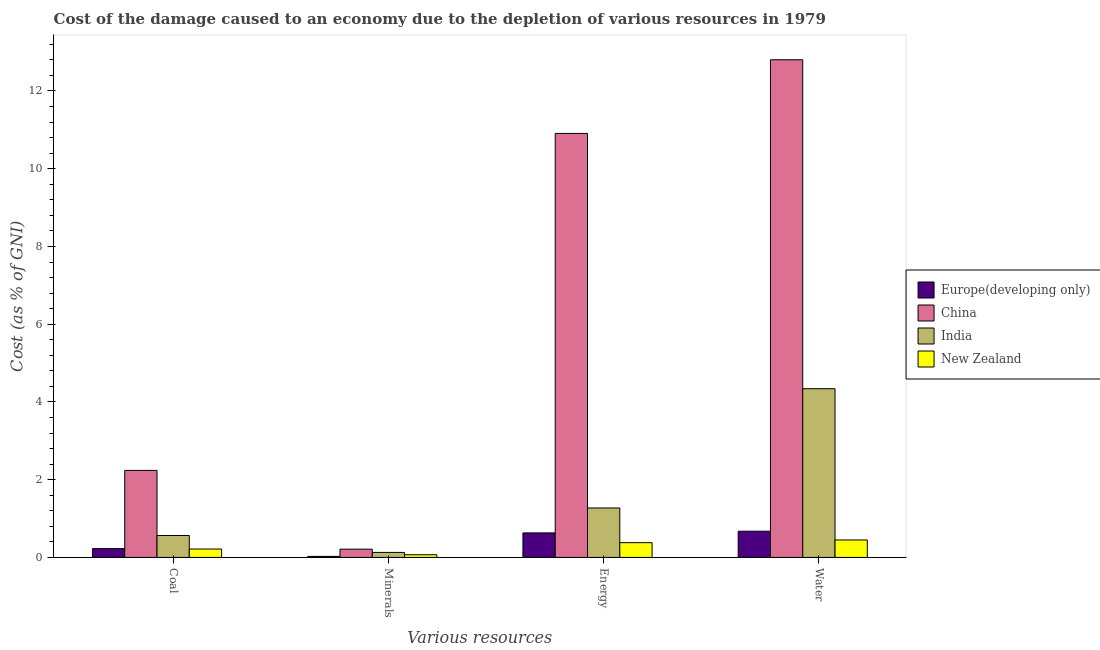How many different coloured bars are there?
Your response must be concise. 4. How many groups of bars are there?
Keep it short and to the point. 4. Are the number of bars per tick equal to the number of legend labels?
Your answer should be very brief. Yes. How many bars are there on the 4th tick from the left?
Provide a succinct answer. 4. How many bars are there on the 2nd tick from the right?
Your answer should be very brief. 4. What is the label of the 1st group of bars from the left?
Offer a terse response. Coal. What is the cost of damage due to depletion of minerals in China?
Offer a terse response. 0.21. Across all countries, what is the maximum cost of damage due to depletion of coal?
Provide a short and direct response. 2.24. Across all countries, what is the minimum cost of damage due to depletion of coal?
Keep it short and to the point. 0.22. In which country was the cost of damage due to depletion of water minimum?
Your answer should be very brief. New Zealand. What is the total cost of damage due to depletion of water in the graph?
Offer a very short reply. 18.27. What is the difference between the cost of damage due to depletion of water in Europe(developing only) and that in China?
Give a very brief answer. -12.13. What is the difference between the cost of damage due to depletion of energy in China and the cost of damage due to depletion of water in India?
Your answer should be compact. 6.57. What is the average cost of damage due to depletion of minerals per country?
Ensure brevity in your answer.  0.11. What is the difference between the cost of damage due to depletion of minerals and cost of damage due to depletion of coal in China?
Offer a terse response. -2.03. What is the ratio of the cost of damage due to depletion of coal in Europe(developing only) to that in India?
Provide a succinct answer. 0.4. Is the cost of damage due to depletion of coal in New Zealand less than that in Europe(developing only)?
Offer a terse response. Yes. Is the difference between the cost of damage due to depletion of water in New Zealand and China greater than the difference between the cost of damage due to depletion of coal in New Zealand and China?
Keep it short and to the point. No. What is the difference between the highest and the second highest cost of damage due to depletion of coal?
Ensure brevity in your answer.  1.67. What is the difference between the highest and the lowest cost of damage due to depletion of energy?
Your answer should be compact. 10.53. Is the sum of the cost of damage due to depletion of coal in China and New Zealand greater than the maximum cost of damage due to depletion of water across all countries?
Provide a succinct answer. No. What does the 3rd bar from the left in Water represents?
Make the answer very short. India. What does the 1st bar from the right in Coal represents?
Keep it short and to the point. New Zealand. Is it the case that in every country, the sum of the cost of damage due to depletion of coal and cost of damage due to depletion of minerals is greater than the cost of damage due to depletion of energy?
Offer a terse response. No. Are all the bars in the graph horizontal?
Offer a terse response. No. How many countries are there in the graph?
Your response must be concise. 4. Are the values on the major ticks of Y-axis written in scientific E-notation?
Keep it short and to the point. No. Does the graph contain any zero values?
Ensure brevity in your answer.  No. How many legend labels are there?
Your answer should be compact. 4. What is the title of the graph?
Your response must be concise. Cost of the damage caused to an economy due to the depletion of various resources in 1979 . What is the label or title of the X-axis?
Offer a very short reply. Various resources. What is the label or title of the Y-axis?
Offer a very short reply. Cost (as % of GNI). What is the Cost (as % of GNI) in Europe(developing only) in Coal?
Give a very brief answer. 0.23. What is the Cost (as % of GNI) of China in Coal?
Make the answer very short. 2.24. What is the Cost (as % of GNI) in India in Coal?
Your answer should be very brief. 0.56. What is the Cost (as % of GNI) in New Zealand in Coal?
Ensure brevity in your answer.  0.22. What is the Cost (as % of GNI) in Europe(developing only) in Minerals?
Your response must be concise. 0.03. What is the Cost (as % of GNI) of China in Minerals?
Your response must be concise. 0.21. What is the Cost (as % of GNI) of India in Minerals?
Keep it short and to the point. 0.13. What is the Cost (as % of GNI) of New Zealand in Minerals?
Offer a very short reply. 0.07. What is the Cost (as % of GNI) of Europe(developing only) in Energy?
Offer a very short reply. 0.63. What is the Cost (as % of GNI) in China in Energy?
Your answer should be compact. 10.91. What is the Cost (as % of GNI) of India in Energy?
Offer a terse response. 1.27. What is the Cost (as % of GNI) in New Zealand in Energy?
Keep it short and to the point. 0.38. What is the Cost (as % of GNI) of Europe(developing only) in Water?
Keep it short and to the point. 0.67. What is the Cost (as % of GNI) of China in Water?
Your answer should be compact. 12.8. What is the Cost (as % of GNI) of India in Water?
Provide a succinct answer. 4.34. What is the Cost (as % of GNI) in New Zealand in Water?
Make the answer very short. 0.45. Across all Various resources, what is the maximum Cost (as % of GNI) in Europe(developing only)?
Make the answer very short. 0.67. Across all Various resources, what is the maximum Cost (as % of GNI) in China?
Your response must be concise. 12.8. Across all Various resources, what is the maximum Cost (as % of GNI) in India?
Your answer should be very brief. 4.34. Across all Various resources, what is the maximum Cost (as % of GNI) of New Zealand?
Offer a terse response. 0.45. Across all Various resources, what is the minimum Cost (as % of GNI) of Europe(developing only)?
Provide a short and direct response. 0.03. Across all Various resources, what is the minimum Cost (as % of GNI) of China?
Your answer should be very brief. 0.21. Across all Various resources, what is the minimum Cost (as % of GNI) of India?
Make the answer very short. 0.13. Across all Various resources, what is the minimum Cost (as % of GNI) of New Zealand?
Provide a succinct answer. 0.07. What is the total Cost (as % of GNI) of Europe(developing only) in the graph?
Your response must be concise. 1.56. What is the total Cost (as % of GNI) in China in the graph?
Your response must be concise. 26.16. What is the total Cost (as % of GNI) of India in the graph?
Your answer should be very brief. 6.31. What is the total Cost (as % of GNI) of New Zealand in the graph?
Ensure brevity in your answer.  1.11. What is the difference between the Cost (as % of GNI) in Europe(developing only) in Coal and that in Minerals?
Offer a terse response. 0.2. What is the difference between the Cost (as % of GNI) in China in Coal and that in Minerals?
Offer a very short reply. 2.03. What is the difference between the Cost (as % of GNI) of India in Coal and that in Minerals?
Offer a terse response. 0.44. What is the difference between the Cost (as % of GNI) of New Zealand in Coal and that in Minerals?
Offer a terse response. 0.15. What is the difference between the Cost (as % of GNI) of Europe(developing only) in Coal and that in Energy?
Ensure brevity in your answer.  -0.4. What is the difference between the Cost (as % of GNI) in China in Coal and that in Energy?
Ensure brevity in your answer.  -8.67. What is the difference between the Cost (as % of GNI) in India in Coal and that in Energy?
Your answer should be compact. -0.71. What is the difference between the Cost (as % of GNI) of New Zealand in Coal and that in Energy?
Your answer should be very brief. -0.16. What is the difference between the Cost (as % of GNI) in Europe(developing only) in Coal and that in Water?
Give a very brief answer. -0.45. What is the difference between the Cost (as % of GNI) of China in Coal and that in Water?
Make the answer very short. -10.56. What is the difference between the Cost (as % of GNI) of India in Coal and that in Water?
Give a very brief answer. -3.78. What is the difference between the Cost (as % of GNI) in New Zealand in Coal and that in Water?
Provide a short and direct response. -0.23. What is the difference between the Cost (as % of GNI) of Europe(developing only) in Minerals and that in Energy?
Give a very brief answer. -0.6. What is the difference between the Cost (as % of GNI) of China in Minerals and that in Energy?
Offer a terse response. -10.7. What is the difference between the Cost (as % of GNI) of India in Minerals and that in Energy?
Ensure brevity in your answer.  -1.14. What is the difference between the Cost (as % of GNI) of New Zealand in Minerals and that in Energy?
Ensure brevity in your answer.  -0.31. What is the difference between the Cost (as % of GNI) of Europe(developing only) in Minerals and that in Water?
Provide a succinct answer. -0.65. What is the difference between the Cost (as % of GNI) in China in Minerals and that in Water?
Your answer should be very brief. -12.59. What is the difference between the Cost (as % of GNI) of India in Minerals and that in Water?
Keep it short and to the point. -4.21. What is the difference between the Cost (as % of GNI) in New Zealand in Minerals and that in Water?
Give a very brief answer. -0.38. What is the difference between the Cost (as % of GNI) of Europe(developing only) in Energy and that in Water?
Give a very brief answer. -0.04. What is the difference between the Cost (as % of GNI) in China in Energy and that in Water?
Your response must be concise. -1.9. What is the difference between the Cost (as % of GNI) in India in Energy and that in Water?
Provide a short and direct response. -3.07. What is the difference between the Cost (as % of GNI) in New Zealand in Energy and that in Water?
Provide a short and direct response. -0.07. What is the difference between the Cost (as % of GNI) in Europe(developing only) in Coal and the Cost (as % of GNI) in China in Minerals?
Keep it short and to the point. 0.01. What is the difference between the Cost (as % of GNI) of Europe(developing only) in Coal and the Cost (as % of GNI) of India in Minerals?
Provide a succinct answer. 0.1. What is the difference between the Cost (as % of GNI) in Europe(developing only) in Coal and the Cost (as % of GNI) in New Zealand in Minerals?
Offer a very short reply. 0.16. What is the difference between the Cost (as % of GNI) in China in Coal and the Cost (as % of GNI) in India in Minerals?
Give a very brief answer. 2.11. What is the difference between the Cost (as % of GNI) of China in Coal and the Cost (as % of GNI) of New Zealand in Minerals?
Provide a short and direct response. 2.17. What is the difference between the Cost (as % of GNI) in India in Coal and the Cost (as % of GNI) in New Zealand in Minerals?
Your answer should be compact. 0.49. What is the difference between the Cost (as % of GNI) in Europe(developing only) in Coal and the Cost (as % of GNI) in China in Energy?
Give a very brief answer. -10.68. What is the difference between the Cost (as % of GNI) in Europe(developing only) in Coal and the Cost (as % of GNI) in India in Energy?
Provide a short and direct response. -1.05. What is the difference between the Cost (as % of GNI) in Europe(developing only) in Coal and the Cost (as % of GNI) in New Zealand in Energy?
Give a very brief answer. -0.15. What is the difference between the Cost (as % of GNI) of China in Coal and the Cost (as % of GNI) of India in Energy?
Make the answer very short. 0.97. What is the difference between the Cost (as % of GNI) of China in Coal and the Cost (as % of GNI) of New Zealand in Energy?
Ensure brevity in your answer.  1.86. What is the difference between the Cost (as % of GNI) in India in Coal and the Cost (as % of GNI) in New Zealand in Energy?
Keep it short and to the point. 0.18. What is the difference between the Cost (as % of GNI) of Europe(developing only) in Coal and the Cost (as % of GNI) of China in Water?
Provide a short and direct response. -12.58. What is the difference between the Cost (as % of GNI) in Europe(developing only) in Coal and the Cost (as % of GNI) in India in Water?
Your response must be concise. -4.11. What is the difference between the Cost (as % of GNI) of Europe(developing only) in Coal and the Cost (as % of GNI) of New Zealand in Water?
Provide a short and direct response. -0.22. What is the difference between the Cost (as % of GNI) of China in Coal and the Cost (as % of GNI) of India in Water?
Provide a succinct answer. -2.1. What is the difference between the Cost (as % of GNI) of China in Coal and the Cost (as % of GNI) of New Zealand in Water?
Offer a very short reply. 1.79. What is the difference between the Cost (as % of GNI) in India in Coal and the Cost (as % of GNI) in New Zealand in Water?
Offer a very short reply. 0.11. What is the difference between the Cost (as % of GNI) in Europe(developing only) in Minerals and the Cost (as % of GNI) in China in Energy?
Your response must be concise. -10.88. What is the difference between the Cost (as % of GNI) in Europe(developing only) in Minerals and the Cost (as % of GNI) in India in Energy?
Your answer should be compact. -1.25. What is the difference between the Cost (as % of GNI) in Europe(developing only) in Minerals and the Cost (as % of GNI) in New Zealand in Energy?
Provide a succinct answer. -0.35. What is the difference between the Cost (as % of GNI) of China in Minerals and the Cost (as % of GNI) of India in Energy?
Your answer should be very brief. -1.06. What is the difference between the Cost (as % of GNI) of China in Minerals and the Cost (as % of GNI) of New Zealand in Energy?
Provide a succinct answer. -0.17. What is the difference between the Cost (as % of GNI) in India in Minerals and the Cost (as % of GNI) in New Zealand in Energy?
Make the answer very short. -0.25. What is the difference between the Cost (as % of GNI) in Europe(developing only) in Minerals and the Cost (as % of GNI) in China in Water?
Your answer should be compact. -12.78. What is the difference between the Cost (as % of GNI) of Europe(developing only) in Minerals and the Cost (as % of GNI) of India in Water?
Your answer should be very brief. -4.31. What is the difference between the Cost (as % of GNI) of Europe(developing only) in Minerals and the Cost (as % of GNI) of New Zealand in Water?
Give a very brief answer. -0.42. What is the difference between the Cost (as % of GNI) of China in Minerals and the Cost (as % of GNI) of India in Water?
Your answer should be very brief. -4.13. What is the difference between the Cost (as % of GNI) in China in Minerals and the Cost (as % of GNI) in New Zealand in Water?
Keep it short and to the point. -0.24. What is the difference between the Cost (as % of GNI) of India in Minerals and the Cost (as % of GNI) of New Zealand in Water?
Your response must be concise. -0.32. What is the difference between the Cost (as % of GNI) in Europe(developing only) in Energy and the Cost (as % of GNI) in China in Water?
Offer a very short reply. -12.17. What is the difference between the Cost (as % of GNI) of Europe(developing only) in Energy and the Cost (as % of GNI) of India in Water?
Provide a succinct answer. -3.71. What is the difference between the Cost (as % of GNI) in Europe(developing only) in Energy and the Cost (as % of GNI) in New Zealand in Water?
Make the answer very short. 0.18. What is the difference between the Cost (as % of GNI) of China in Energy and the Cost (as % of GNI) of India in Water?
Ensure brevity in your answer.  6.57. What is the difference between the Cost (as % of GNI) of China in Energy and the Cost (as % of GNI) of New Zealand in Water?
Keep it short and to the point. 10.46. What is the difference between the Cost (as % of GNI) of India in Energy and the Cost (as % of GNI) of New Zealand in Water?
Provide a short and direct response. 0.82. What is the average Cost (as % of GNI) of Europe(developing only) per Various resources?
Offer a very short reply. 0.39. What is the average Cost (as % of GNI) of China per Various resources?
Make the answer very short. 6.54. What is the average Cost (as % of GNI) in India per Various resources?
Make the answer very short. 1.58. What is the average Cost (as % of GNI) in New Zealand per Various resources?
Keep it short and to the point. 0.28. What is the difference between the Cost (as % of GNI) of Europe(developing only) and Cost (as % of GNI) of China in Coal?
Give a very brief answer. -2.01. What is the difference between the Cost (as % of GNI) in Europe(developing only) and Cost (as % of GNI) in India in Coal?
Your answer should be very brief. -0.34. What is the difference between the Cost (as % of GNI) in Europe(developing only) and Cost (as % of GNI) in New Zealand in Coal?
Offer a very short reply. 0.01. What is the difference between the Cost (as % of GNI) in China and Cost (as % of GNI) in India in Coal?
Provide a short and direct response. 1.67. What is the difference between the Cost (as % of GNI) in China and Cost (as % of GNI) in New Zealand in Coal?
Your answer should be compact. 2.02. What is the difference between the Cost (as % of GNI) in India and Cost (as % of GNI) in New Zealand in Coal?
Your answer should be compact. 0.35. What is the difference between the Cost (as % of GNI) of Europe(developing only) and Cost (as % of GNI) of China in Minerals?
Your answer should be compact. -0.19. What is the difference between the Cost (as % of GNI) in Europe(developing only) and Cost (as % of GNI) in India in Minerals?
Offer a very short reply. -0.1. What is the difference between the Cost (as % of GNI) of Europe(developing only) and Cost (as % of GNI) of New Zealand in Minerals?
Your response must be concise. -0.04. What is the difference between the Cost (as % of GNI) of China and Cost (as % of GNI) of India in Minerals?
Your answer should be very brief. 0.08. What is the difference between the Cost (as % of GNI) of China and Cost (as % of GNI) of New Zealand in Minerals?
Make the answer very short. 0.14. What is the difference between the Cost (as % of GNI) in India and Cost (as % of GNI) in New Zealand in Minerals?
Ensure brevity in your answer.  0.06. What is the difference between the Cost (as % of GNI) in Europe(developing only) and Cost (as % of GNI) in China in Energy?
Offer a very short reply. -10.28. What is the difference between the Cost (as % of GNI) of Europe(developing only) and Cost (as % of GNI) of India in Energy?
Offer a very short reply. -0.64. What is the difference between the Cost (as % of GNI) of Europe(developing only) and Cost (as % of GNI) of New Zealand in Energy?
Offer a very short reply. 0.25. What is the difference between the Cost (as % of GNI) in China and Cost (as % of GNI) in India in Energy?
Offer a very short reply. 9.64. What is the difference between the Cost (as % of GNI) of China and Cost (as % of GNI) of New Zealand in Energy?
Give a very brief answer. 10.53. What is the difference between the Cost (as % of GNI) in India and Cost (as % of GNI) in New Zealand in Energy?
Ensure brevity in your answer.  0.89. What is the difference between the Cost (as % of GNI) in Europe(developing only) and Cost (as % of GNI) in China in Water?
Provide a succinct answer. -12.13. What is the difference between the Cost (as % of GNI) of Europe(developing only) and Cost (as % of GNI) of India in Water?
Ensure brevity in your answer.  -3.67. What is the difference between the Cost (as % of GNI) in Europe(developing only) and Cost (as % of GNI) in New Zealand in Water?
Keep it short and to the point. 0.22. What is the difference between the Cost (as % of GNI) of China and Cost (as % of GNI) of India in Water?
Give a very brief answer. 8.46. What is the difference between the Cost (as % of GNI) of China and Cost (as % of GNI) of New Zealand in Water?
Ensure brevity in your answer.  12.35. What is the difference between the Cost (as % of GNI) in India and Cost (as % of GNI) in New Zealand in Water?
Your response must be concise. 3.89. What is the ratio of the Cost (as % of GNI) in Europe(developing only) in Coal to that in Minerals?
Ensure brevity in your answer.  8.51. What is the ratio of the Cost (as % of GNI) in China in Coal to that in Minerals?
Ensure brevity in your answer.  10.54. What is the ratio of the Cost (as % of GNI) of India in Coal to that in Minerals?
Give a very brief answer. 4.38. What is the ratio of the Cost (as % of GNI) in New Zealand in Coal to that in Minerals?
Ensure brevity in your answer.  3.11. What is the ratio of the Cost (as % of GNI) of Europe(developing only) in Coal to that in Energy?
Ensure brevity in your answer.  0.36. What is the ratio of the Cost (as % of GNI) in China in Coal to that in Energy?
Make the answer very short. 0.21. What is the ratio of the Cost (as % of GNI) in India in Coal to that in Energy?
Give a very brief answer. 0.44. What is the ratio of the Cost (as % of GNI) of New Zealand in Coal to that in Energy?
Offer a terse response. 0.57. What is the ratio of the Cost (as % of GNI) in Europe(developing only) in Coal to that in Water?
Your answer should be compact. 0.34. What is the ratio of the Cost (as % of GNI) of China in Coal to that in Water?
Offer a terse response. 0.17. What is the ratio of the Cost (as % of GNI) of India in Coal to that in Water?
Keep it short and to the point. 0.13. What is the ratio of the Cost (as % of GNI) in New Zealand in Coal to that in Water?
Your response must be concise. 0.48. What is the ratio of the Cost (as % of GNI) in Europe(developing only) in Minerals to that in Energy?
Offer a very short reply. 0.04. What is the ratio of the Cost (as % of GNI) of China in Minerals to that in Energy?
Offer a terse response. 0.02. What is the ratio of the Cost (as % of GNI) of India in Minerals to that in Energy?
Provide a succinct answer. 0.1. What is the ratio of the Cost (as % of GNI) in New Zealand in Minerals to that in Energy?
Provide a succinct answer. 0.18. What is the ratio of the Cost (as % of GNI) in Europe(developing only) in Minerals to that in Water?
Your response must be concise. 0.04. What is the ratio of the Cost (as % of GNI) in China in Minerals to that in Water?
Your answer should be very brief. 0.02. What is the ratio of the Cost (as % of GNI) in India in Minerals to that in Water?
Make the answer very short. 0.03. What is the ratio of the Cost (as % of GNI) in New Zealand in Minerals to that in Water?
Keep it short and to the point. 0.15. What is the ratio of the Cost (as % of GNI) in Europe(developing only) in Energy to that in Water?
Offer a terse response. 0.94. What is the ratio of the Cost (as % of GNI) in China in Energy to that in Water?
Offer a very short reply. 0.85. What is the ratio of the Cost (as % of GNI) of India in Energy to that in Water?
Your response must be concise. 0.29. What is the ratio of the Cost (as % of GNI) of New Zealand in Energy to that in Water?
Your answer should be very brief. 0.85. What is the difference between the highest and the second highest Cost (as % of GNI) of Europe(developing only)?
Your response must be concise. 0.04. What is the difference between the highest and the second highest Cost (as % of GNI) in China?
Make the answer very short. 1.9. What is the difference between the highest and the second highest Cost (as % of GNI) in India?
Ensure brevity in your answer.  3.07. What is the difference between the highest and the second highest Cost (as % of GNI) of New Zealand?
Keep it short and to the point. 0.07. What is the difference between the highest and the lowest Cost (as % of GNI) of Europe(developing only)?
Offer a very short reply. 0.65. What is the difference between the highest and the lowest Cost (as % of GNI) of China?
Provide a short and direct response. 12.59. What is the difference between the highest and the lowest Cost (as % of GNI) in India?
Keep it short and to the point. 4.21. What is the difference between the highest and the lowest Cost (as % of GNI) of New Zealand?
Keep it short and to the point. 0.38. 